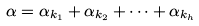Convert formula to latex. <formula><loc_0><loc_0><loc_500><loc_500>\alpha = \alpha _ { k _ { 1 } } + \alpha _ { k _ { 2 } } + \dots + \alpha _ { k _ { h } }</formula> 